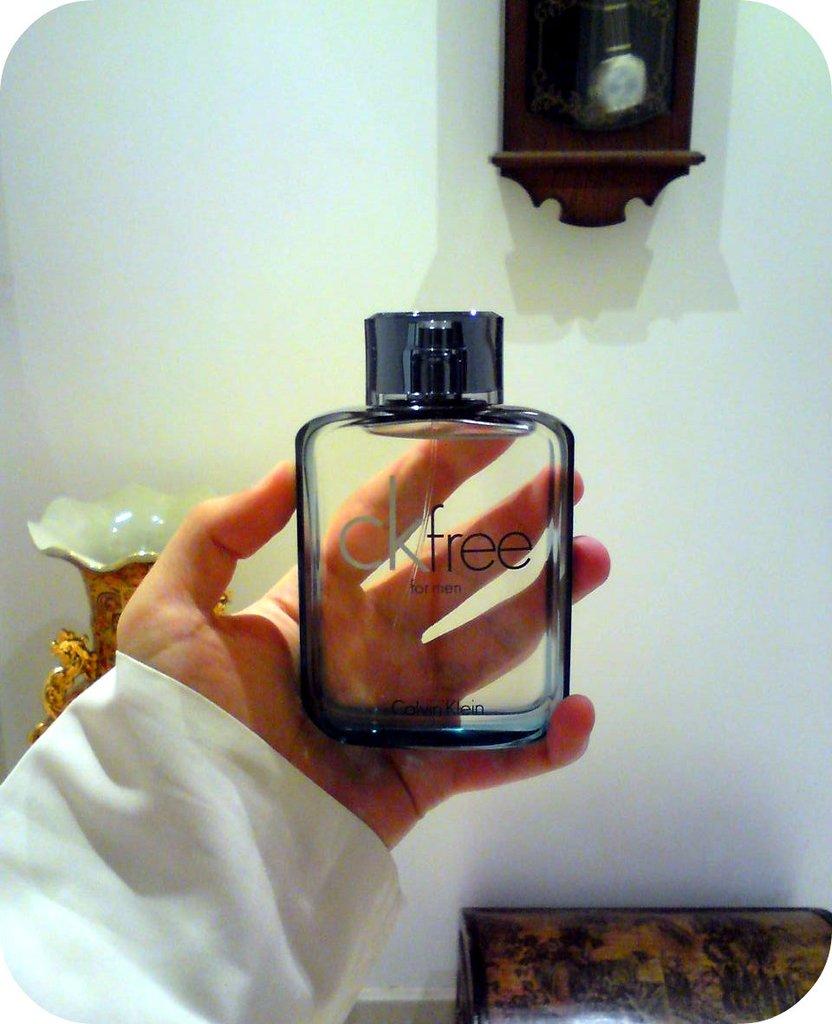What is the name of the fragrance?
Provide a short and direct response. Ckfree. 